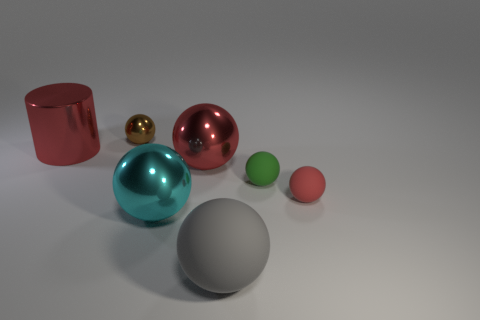There is a green thing that is the same shape as the tiny brown thing; what is its material?
Offer a terse response. Rubber. Are there any other things that have the same material as the cylinder?
Offer a very short reply. Yes. What number of purple things are tiny objects or small shiny objects?
Provide a short and direct response. 0. There is a thing behind the big red cylinder; what is it made of?
Provide a short and direct response. Metal. Is the number of big gray shiny blocks greater than the number of big cyan shiny things?
Your answer should be compact. No. There is a small matte thing to the left of the red matte object; is it the same shape as the big cyan thing?
Offer a terse response. Yes. What number of metal things are both to the left of the red metallic ball and right of the cylinder?
Your answer should be very brief. 2. How many large blue things are the same shape as the cyan metallic thing?
Your answer should be compact. 0. What is the color of the big ball that is in front of the big shiny object that is in front of the tiny red matte object?
Your response must be concise. Gray. Does the small red thing have the same shape as the tiny thing that is on the left side of the big gray rubber thing?
Your answer should be compact. Yes. 